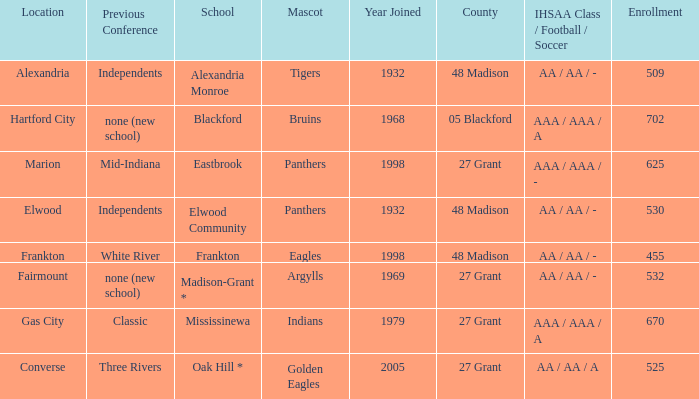What is the previous conference when the location is converse? Three Rivers. 